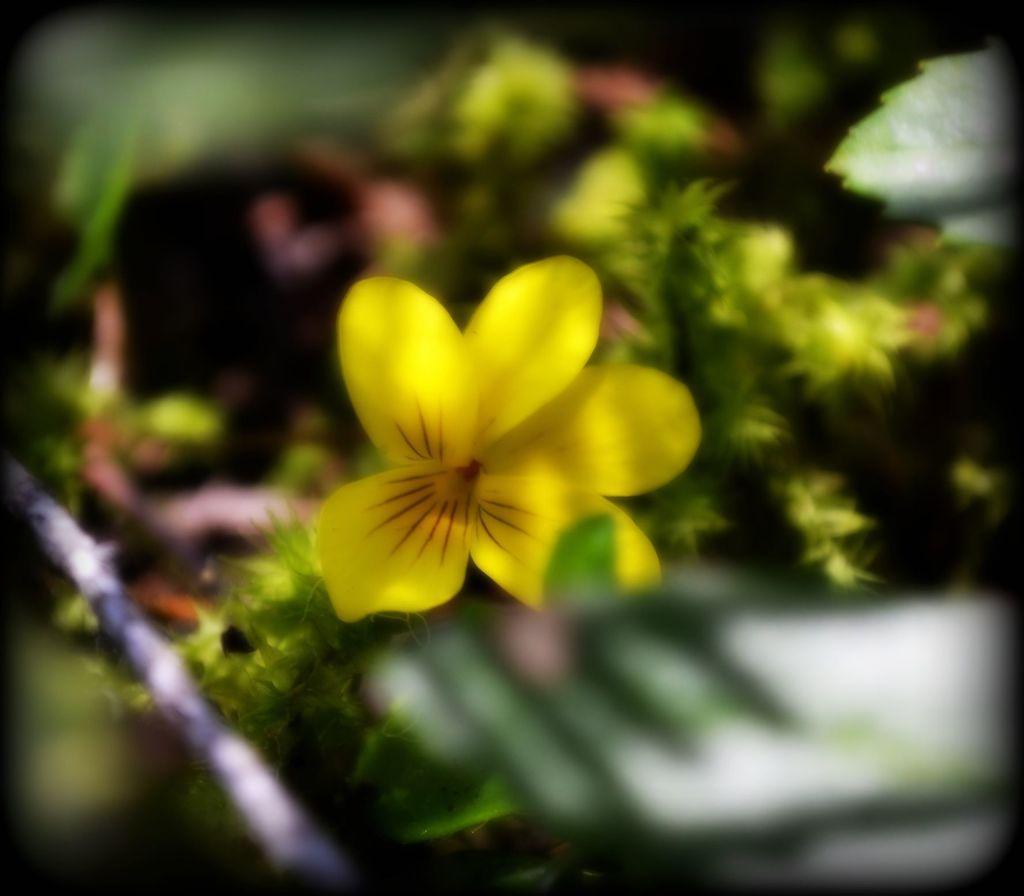What type of plant is visible in the image? There is a yellow flower in the image. What else can be seen in the image besides the flower? There are leaves in the image. Is there any other object present in the image? Yes, there is a thread in the image. What team is the flower supporting in the image? There is no indication of a team or any sports-related context in the image. 